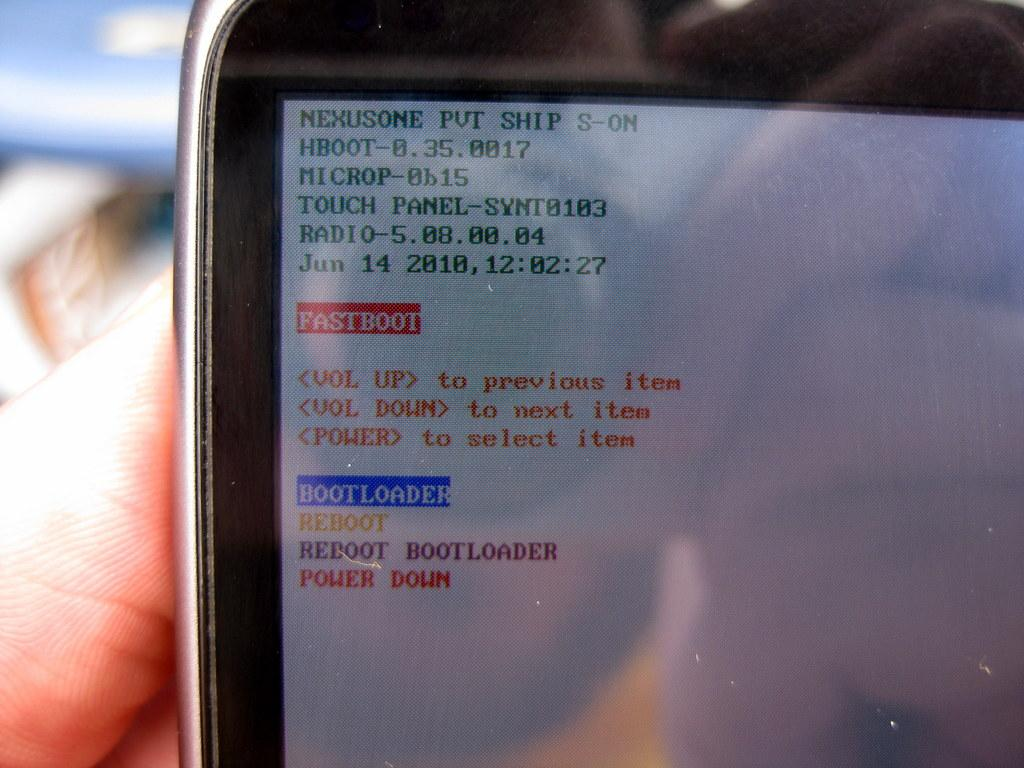Provide a one-sentence caption for the provided image. A screen displays green text with the first word as nexusome. 